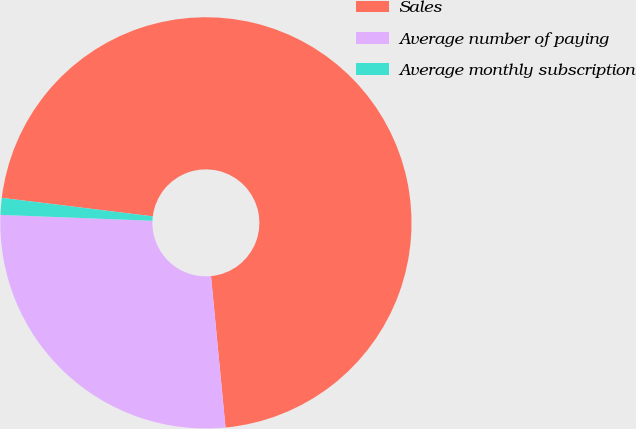<chart> <loc_0><loc_0><loc_500><loc_500><pie_chart><fcel>Sales<fcel>Average number of paying<fcel>Average monthly subscription<nl><fcel>71.54%<fcel>27.14%<fcel>1.32%<nl></chart> 